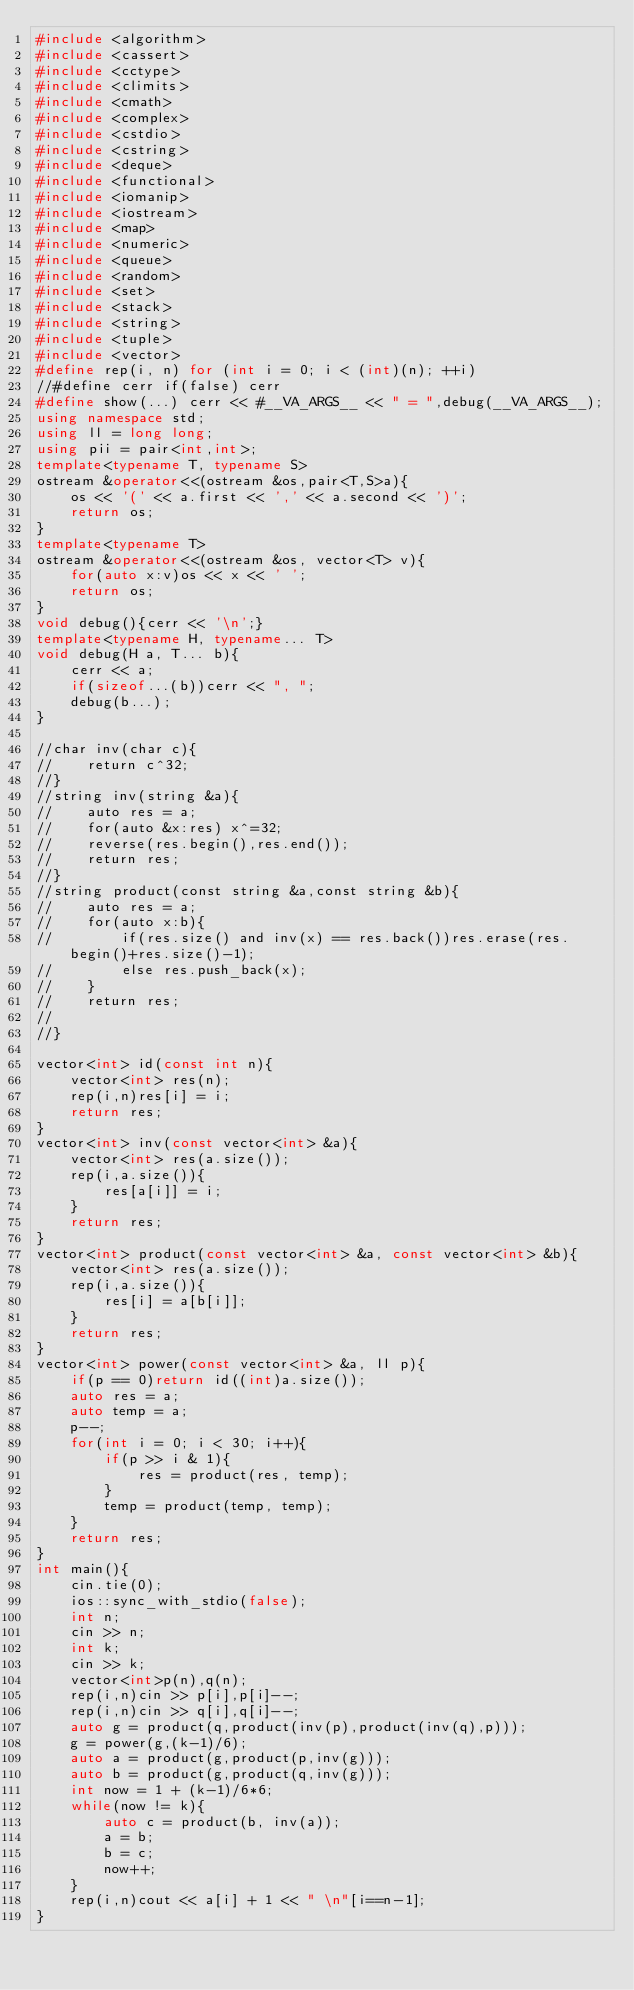<code> <loc_0><loc_0><loc_500><loc_500><_C++_>#include <algorithm>
#include <cassert>
#include <cctype>
#include <climits>
#include <cmath>
#include <complex>
#include <cstdio>
#include <cstring>
#include <deque>
#include <functional>
#include <iomanip>
#include <iostream>
#include <map>
#include <numeric>
#include <queue>
#include <random>
#include <set>
#include <stack>
#include <string>
#include <tuple>
#include <vector>
#define rep(i, n) for (int i = 0; i < (int)(n); ++i)
//#define cerr if(false) cerr
#define show(...) cerr << #__VA_ARGS__ << " = ",debug(__VA_ARGS__);
using namespace std;
using ll = long long;
using pii = pair<int,int>;
template<typename T, typename S>
ostream &operator<<(ostream &os,pair<T,S>a){
    os << '(' << a.first << ',' << a.second << ')';
    return os;
}
template<typename T>
ostream &operator<<(ostream &os, vector<T> v){
    for(auto x:v)os << x << ' ';
    return os;
}
void debug(){cerr << '\n';}
template<typename H, typename... T>
void debug(H a, T... b){
    cerr << a;
    if(sizeof...(b))cerr << ", ";
    debug(b...);
}

//char inv(char c){
//    return c^32;
//}
//string inv(string &a){
//    auto res = a;
//    for(auto &x:res) x^=32;
//    reverse(res.begin(),res.end());
//    return res;
//}
//string product(const string &a,const string &b){
//    auto res = a;
//    for(auto x:b){
//        if(res.size() and inv(x) == res.back())res.erase(res.begin()+res.size()-1);
//        else res.push_back(x);
//    }
//    return res;
//    
//}

vector<int> id(const int n){
    vector<int> res(n);
    rep(i,n)res[i] = i;
    return res;
}
vector<int> inv(const vector<int> &a){
    vector<int> res(a.size());
    rep(i,a.size()){
        res[a[i]] = i;
    }
    return res;
}
vector<int> product(const vector<int> &a, const vector<int> &b){
    vector<int> res(a.size());
    rep(i,a.size()){
        res[i] = a[b[i]];
    }
    return res;
}
vector<int> power(const vector<int> &a, ll p){
    if(p == 0)return id((int)a.size());
    auto res = a;
    auto temp = a;
    p--;
    for(int i = 0; i < 30; i++){
        if(p >> i & 1){
            res = product(res, temp);
        }
        temp = product(temp, temp);
    }
    return res;
}
int main(){
    cin.tie(0);
    ios::sync_with_stdio(false);
    int n;
    cin >> n;
    int k;
    cin >> k;
    vector<int>p(n),q(n);
    rep(i,n)cin >> p[i],p[i]--;
    rep(i,n)cin >> q[i],q[i]--;
    auto g = product(q,product(inv(p),product(inv(q),p)));
    g = power(g,(k-1)/6);
    auto a = product(g,product(p,inv(g)));
    auto b = product(g,product(q,inv(g)));
    int now = 1 + (k-1)/6*6;
    while(now != k){
        auto c = product(b, inv(a));
        a = b;
        b = c;
        now++;
    }
    rep(i,n)cout << a[i] + 1 << " \n"[i==n-1];
}</code> 